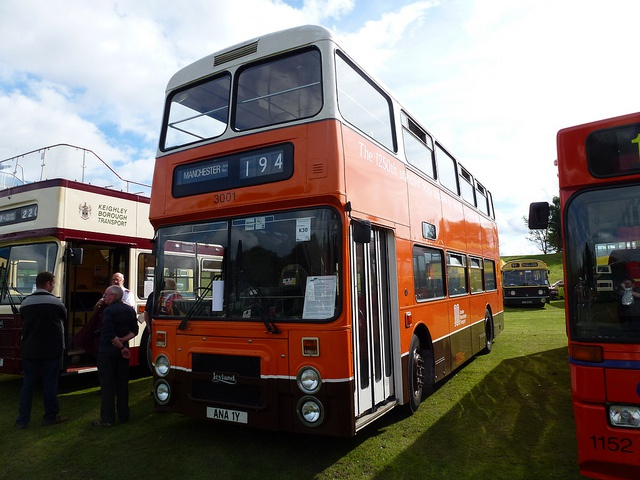Describe the objects in this image and their specific colors. I can see bus in lightgray, black, white, gray, and maroon tones, bus in lightgray, black, maroon, and darkblue tones, bus in lightgray, black, darkgray, and gray tones, people in lightgray, black, gray, purple, and maroon tones, and people in lightgray, black, maroon, gray, and darkgray tones in this image. 